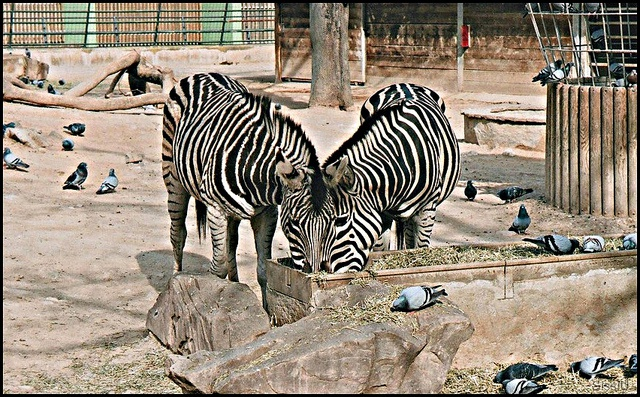Describe the objects in this image and their specific colors. I can see zebra in black, ivory, gray, and darkgray tones, zebra in black, ivory, gray, and darkgray tones, bird in black, lightgray, darkgray, and gray tones, bird in black, gray, purple, and ivory tones, and bird in black, lightgray, darkgray, and gray tones in this image. 